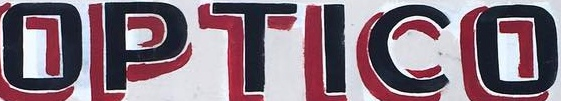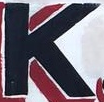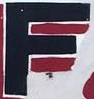What text appears in these images from left to right, separated by a semicolon? OPTICO; K; F 